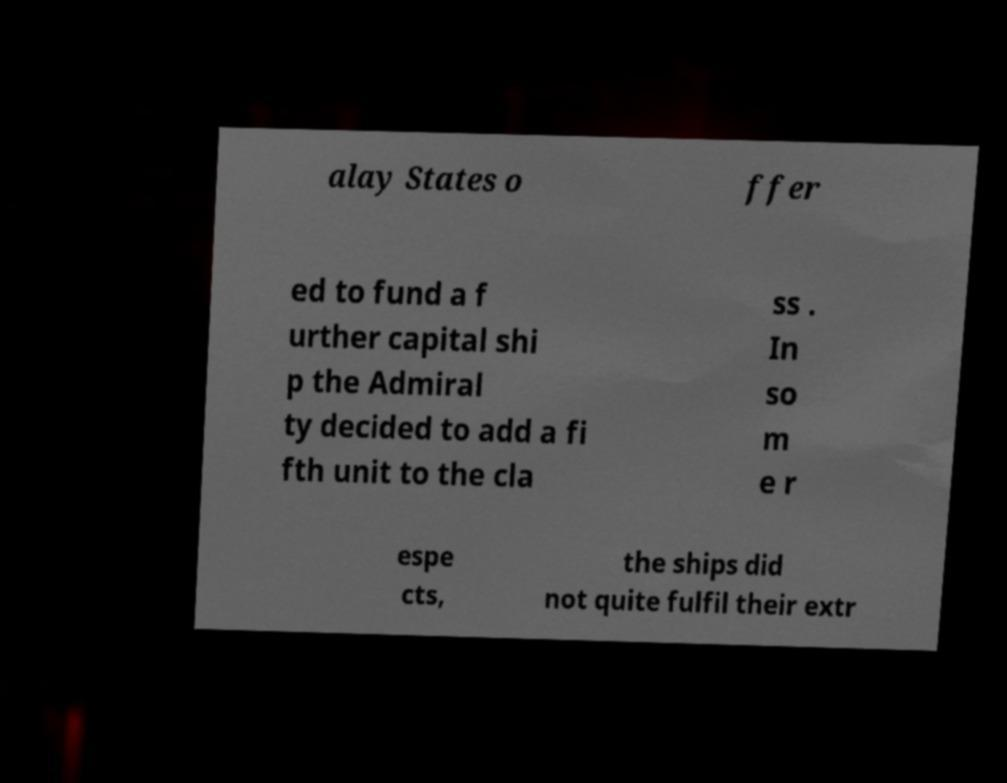Can you accurately transcribe the text from the provided image for me? alay States o ffer ed to fund a f urther capital shi p the Admiral ty decided to add a fi fth unit to the cla ss . In so m e r espe cts, the ships did not quite fulfil their extr 